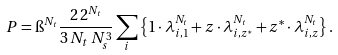Convert formula to latex. <formula><loc_0><loc_0><loc_500><loc_500>P = \i ^ { N _ { t } } \frac { 2 \, 2 ^ { N _ { t } } } { 3 \, N _ { t } \, N _ { s } ^ { 3 } } \sum _ { i } \left \{ 1 \cdot \lambda _ { i , 1 } ^ { N _ { t } } + z \cdot \lambda _ { i , z ^ { \ast } } ^ { N _ { t } } + z ^ { \ast } \cdot \lambda _ { i , z } ^ { N _ { t } } \right \} .</formula> 